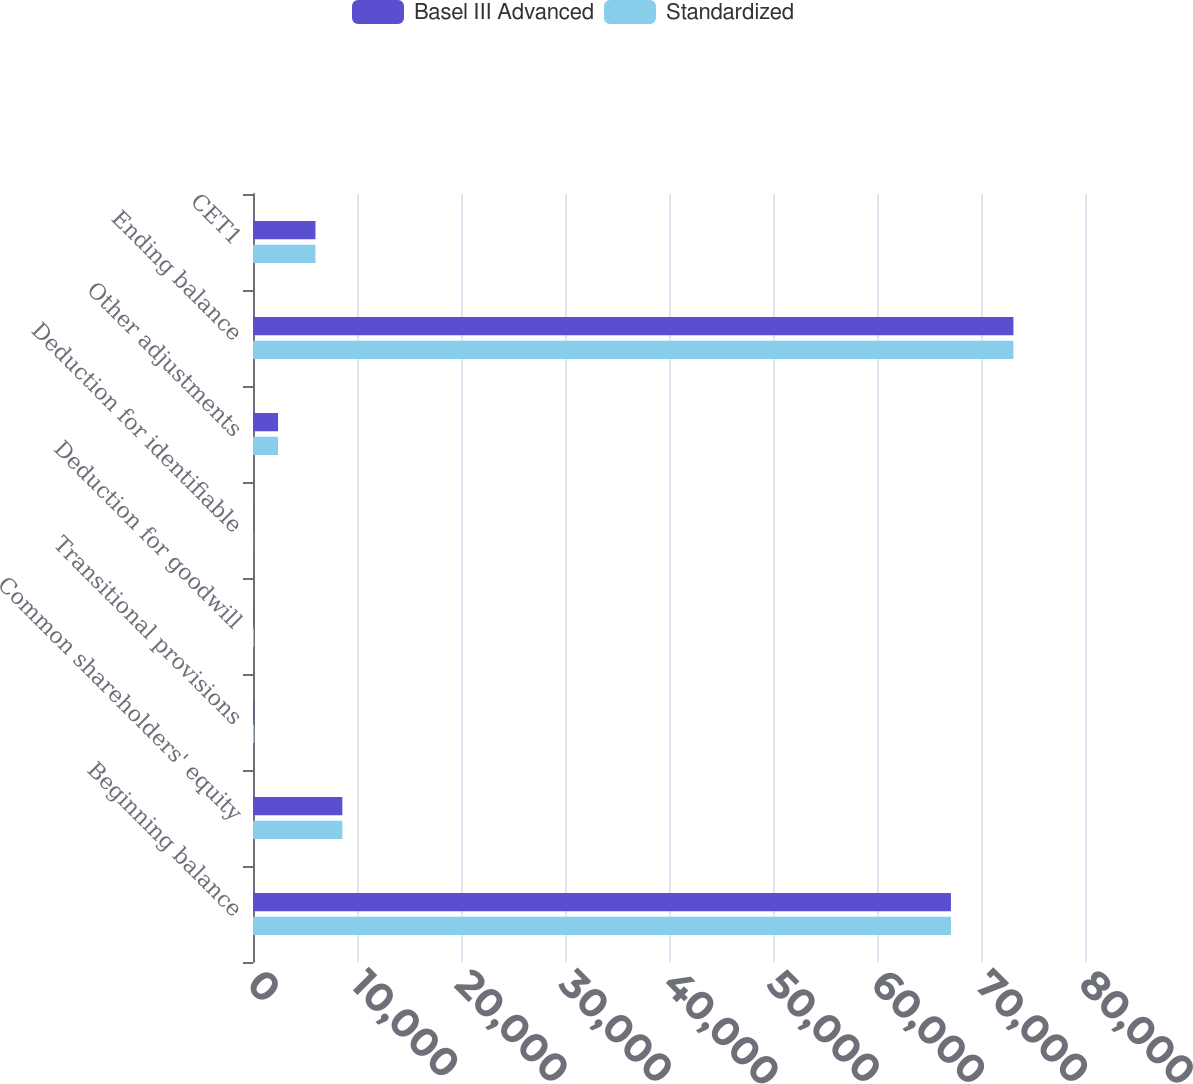Convert chart to OTSL. <chart><loc_0><loc_0><loc_500><loc_500><stacked_bar_chart><ecel><fcel>Beginning balance<fcel>Common shareholders' equity<fcel>Transitional provisions<fcel>Deduction for goodwill<fcel>Deduction for identifiable<fcel>Other adjustments<fcel>Ending balance<fcel>CET1<nl><fcel>Basel III Advanced<fcel>67110<fcel>8592<fcel>117<fcel>86<fcel>26<fcel>2409<fcel>73116<fcel>6006<nl><fcel>Standardized<fcel>67110<fcel>8592<fcel>117<fcel>86<fcel>26<fcel>2409<fcel>73116<fcel>6006<nl></chart> 